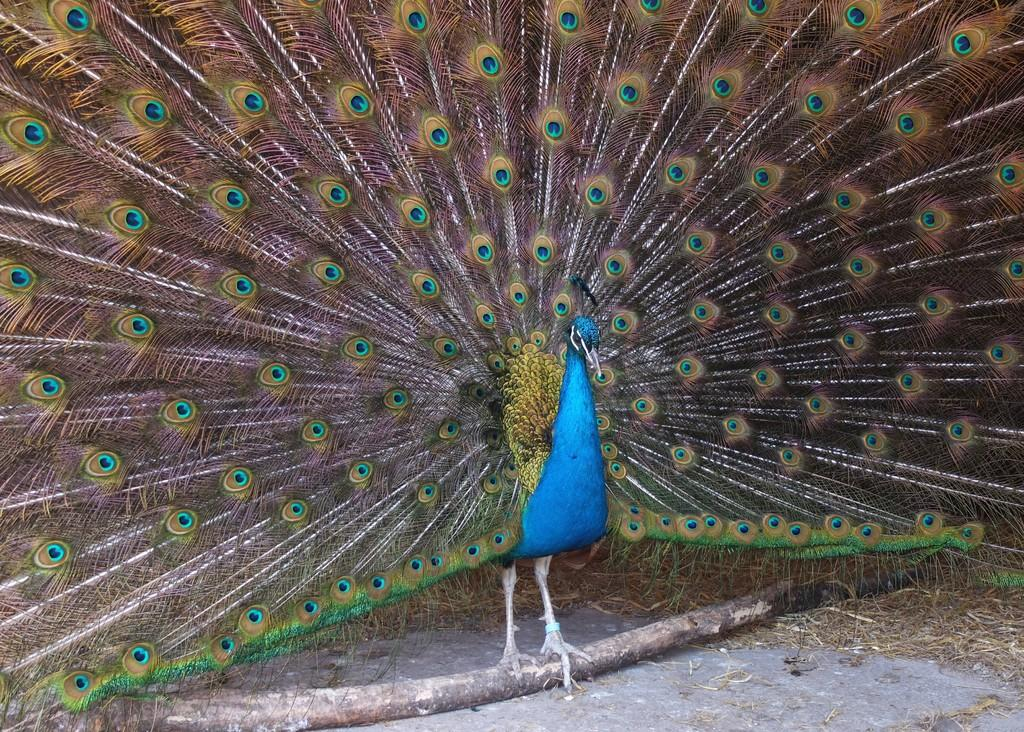What type of animal is in the image? There is a peacock in the image. What is the peacock standing on? The peacock is standing on a wooden pole. What can be seen on the surface at the bottom of the image? Dried grass is present on the surface at the bottom of the image. Is the camera visible in the image? There is no camera present in the image. How can we determine if the peacock is making any noise in the image? The image is silent, and we cannot determine if the peacock is making any noise based on the visual information provided. 